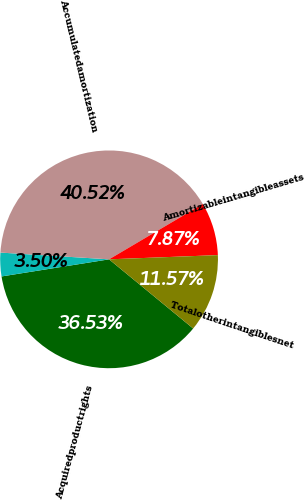<chart> <loc_0><loc_0><loc_500><loc_500><pie_chart><fcel>Acquiredproductrights<fcel>Unnamed: 1<fcel>Accumulatedamortization<fcel>Amortizableintangibleassets<fcel>Totalotherintangiblesnet<nl><fcel>36.53%<fcel>3.5%<fcel>40.52%<fcel>7.87%<fcel>11.57%<nl></chart> 